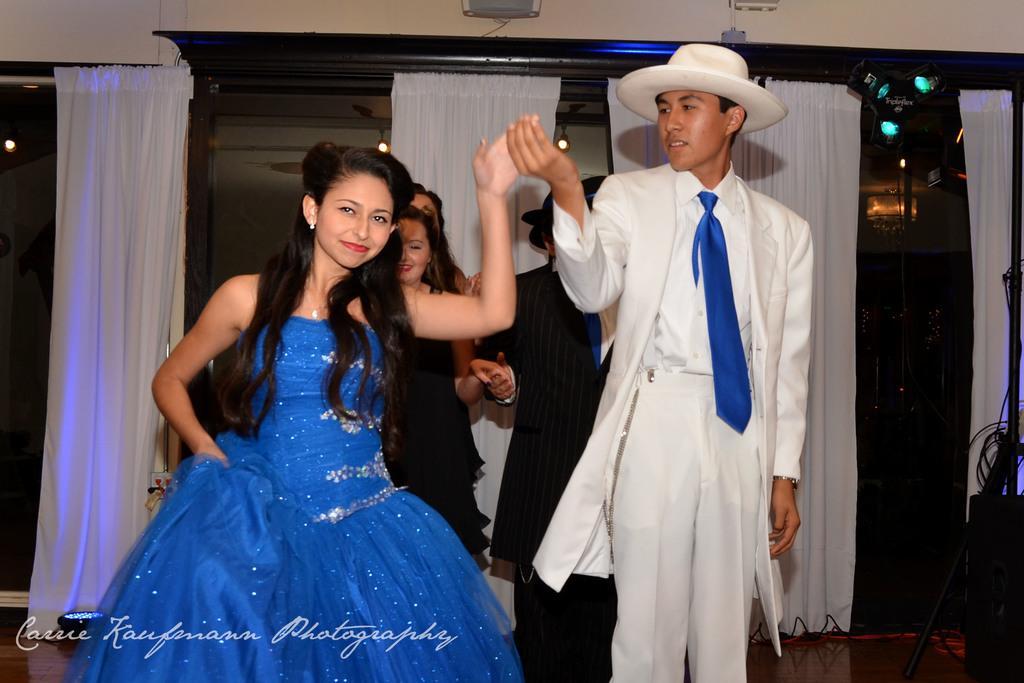Describe this image in one or two sentences. This image is clicked inside a room. There are curtains in the middle. There are some persons in the middle. There are lights at the top. In the front there are two persons, one is man, another one is a woman. They are holding hands. 